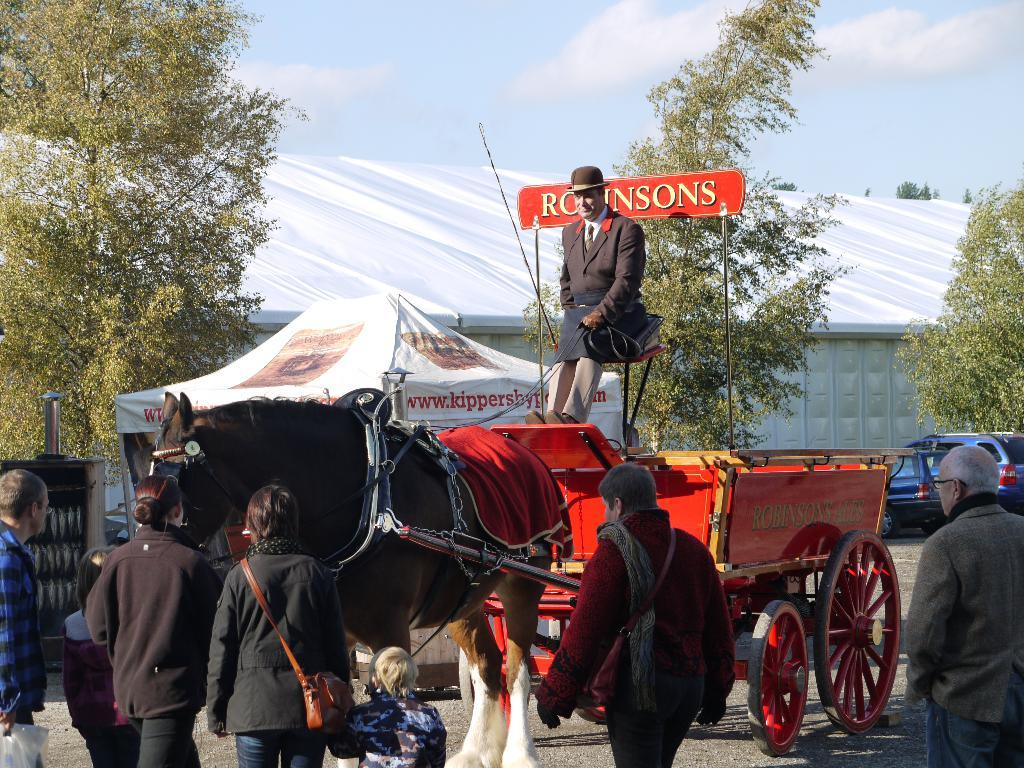What is the main subject of the image? The main subject of the image is a horse with a cart. Who is on the cart? A person is sitting on the cart. What can be seen in the distance? There is a tent and a vehicle in the distance. What type of vegetation is present in the image? There are trees in the image. Are there any other people in the image besides the person on the cart? Yes, there are people standing in the image. What type of cover is being used to protect the horse from the heat in the image? There is no mention of heat or a cover to protect the horse in the image. The horse is not shown to be in any discomfort or need of protection from the heat. 